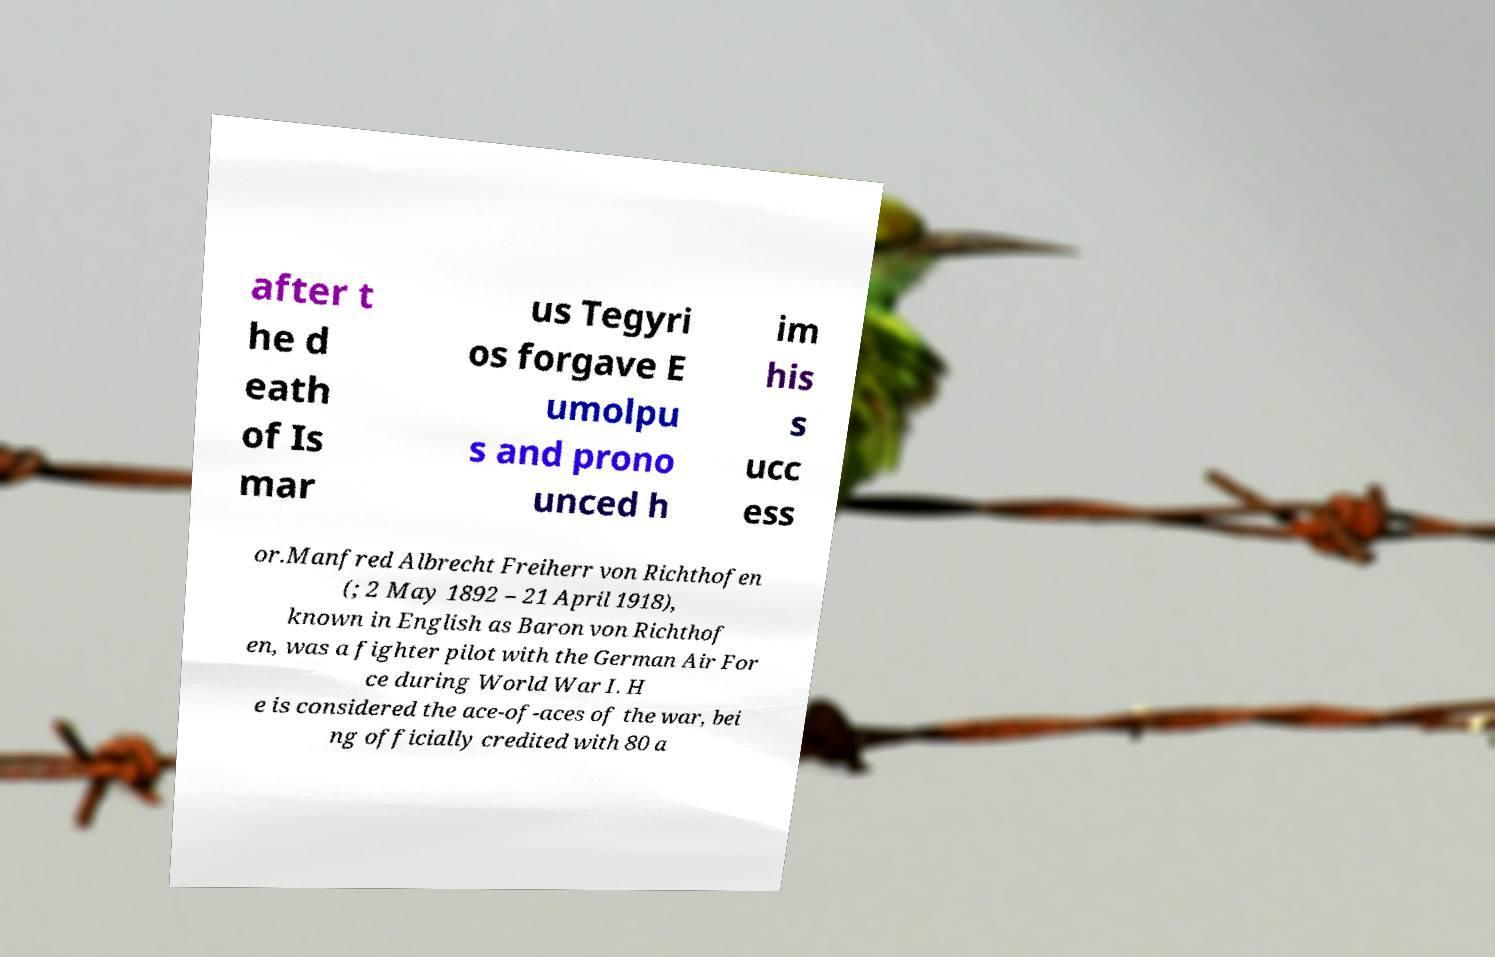Could you extract and type out the text from this image? after t he d eath of Is mar us Tegyri os forgave E umolpu s and prono unced h im his s ucc ess or.Manfred Albrecht Freiherr von Richthofen (; 2 May 1892 – 21 April 1918), known in English as Baron von Richthof en, was a fighter pilot with the German Air For ce during World War I. H e is considered the ace-of-aces of the war, bei ng officially credited with 80 a 